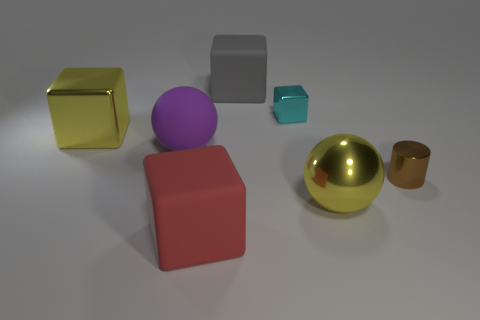There is a large purple rubber object; does it have the same shape as the big yellow shiny thing behind the cylinder?
Provide a succinct answer. No. What color is the matte block behind the brown metallic cylinder?
Provide a succinct answer. Gray. There is a metal cube that is to the right of the rubber cube that is behind the large yellow metallic ball; what size is it?
Your answer should be compact. Small. There is a large rubber object behind the large rubber sphere; is its shape the same as the red matte object?
Ensure brevity in your answer.  Yes. What material is the tiny object that is the same shape as the large red object?
Provide a succinct answer. Metal. How many objects are either big rubber objects that are in front of the yellow ball or rubber blocks behind the large matte ball?
Offer a terse response. 2. Do the cylinder and the matte cube that is in front of the small cyan cube have the same color?
Offer a terse response. No. What is the shape of the tiny thing that is made of the same material as the tiny brown cylinder?
Ensure brevity in your answer.  Cube. How many tiny blue rubber cubes are there?
Keep it short and to the point. 0. How many things are either big matte cubes that are behind the big matte sphere or large matte things?
Your response must be concise. 3. 